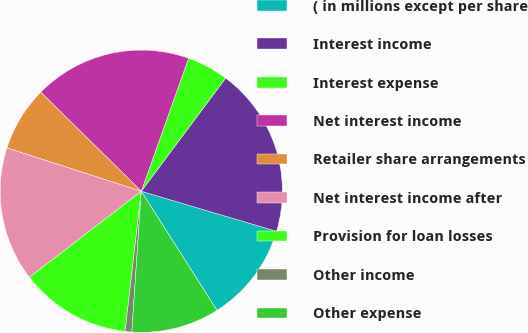Convert chart. <chart><loc_0><loc_0><loc_500><loc_500><pie_chart><fcel>( in millions except per share<fcel>Interest income<fcel>Interest expense<fcel>Net interest income<fcel>Retailer share arrangements<fcel>Net interest income after<fcel>Provision for loan losses<fcel>Other income<fcel>Other expense<nl><fcel>11.41%<fcel>19.39%<fcel>4.76%<fcel>18.06%<fcel>7.42%<fcel>15.4%<fcel>12.74%<fcel>0.76%<fcel>10.08%<nl></chart> 